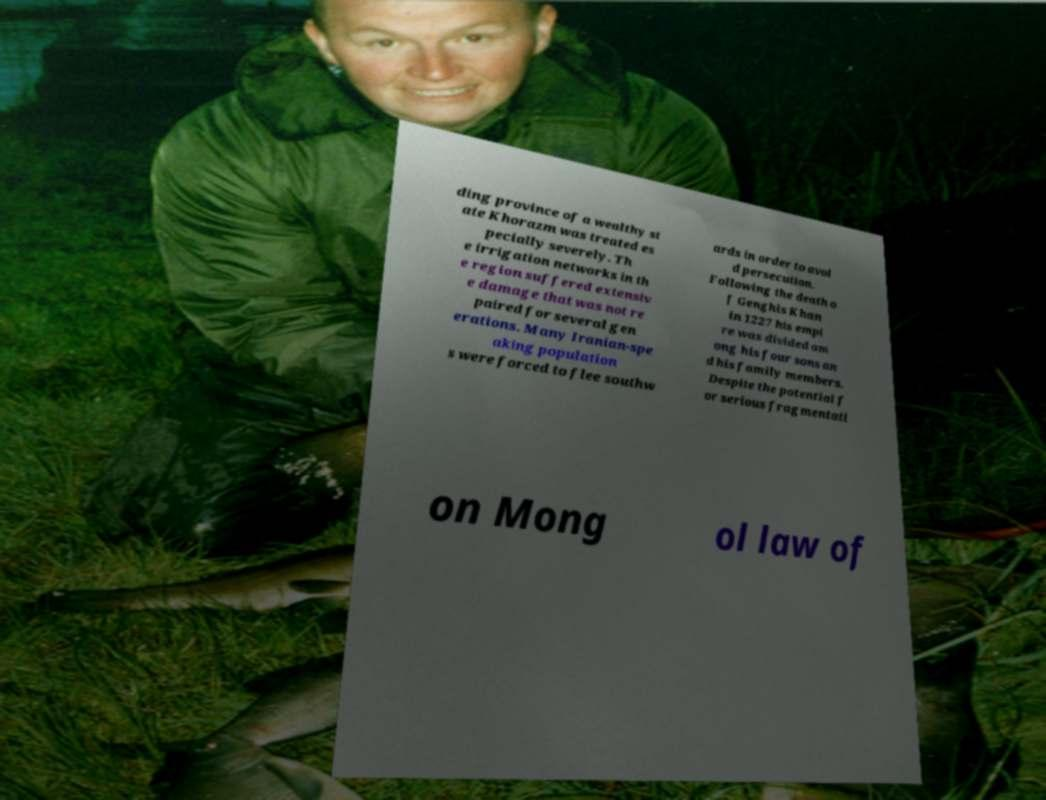Could you assist in decoding the text presented in this image and type it out clearly? ding province of a wealthy st ate Khorazm was treated es pecially severely. Th e irrigation networks in th e region suffered extensiv e damage that was not re paired for several gen erations. Many Iranian-spe aking population s were forced to flee southw ards in order to avoi d persecution. Following the death o f Genghis Khan in 1227 his empi re was divided am ong his four sons an d his family members. Despite the potential f or serious fragmentati on Mong ol law of 